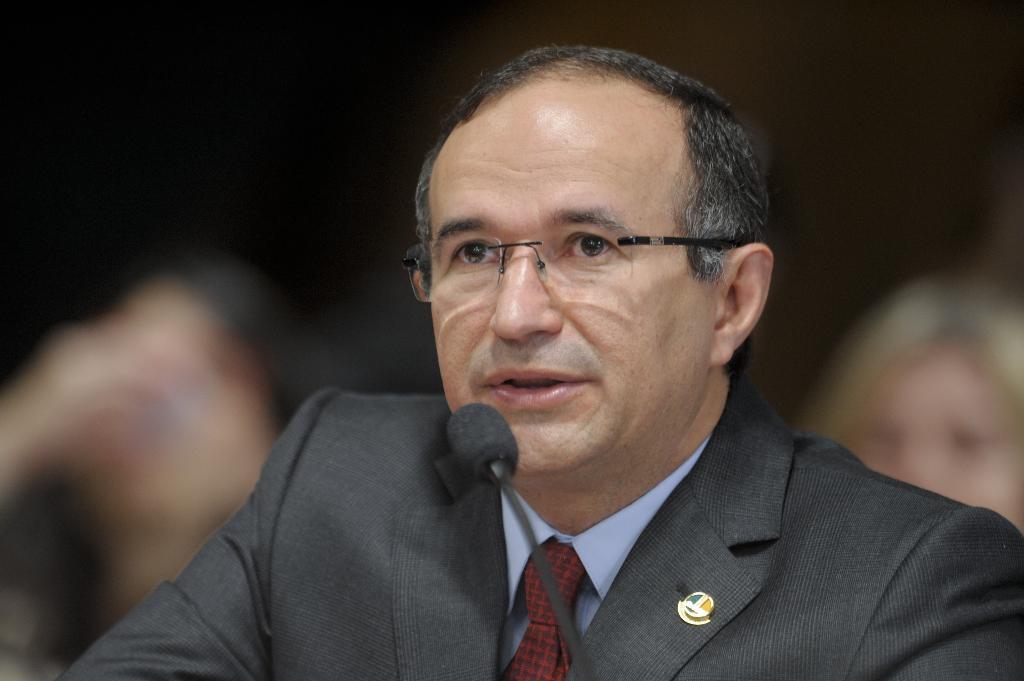Could you give a brief overview of what you see in this image? In this image, I can see the man. This is a mike. He wore a suit, tie, shirt and spectacle. This looks like a small badge, which is attached to the suit. The background looks blurry. 